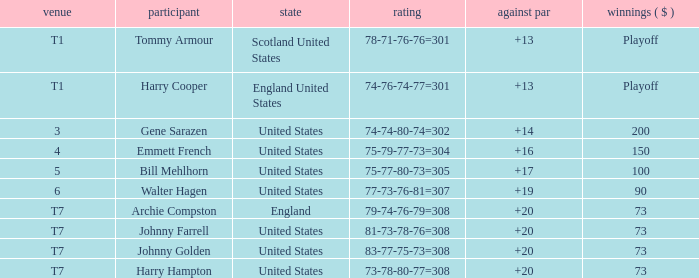What is the ranking when Archie Compston is the player and the money is $73? T7. Would you mind parsing the complete table? {'header': ['venue', 'participant', 'state', 'rating', 'against par', 'winnings ( $ )'], 'rows': [['T1', 'Tommy Armour', 'Scotland United States', '78-71-76-76=301', '+13', 'Playoff'], ['T1', 'Harry Cooper', 'England United States', '74-76-74-77=301', '+13', 'Playoff'], ['3', 'Gene Sarazen', 'United States', '74-74-80-74=302', '+14', '200'], ['4', 'Emmett French', 'United States', '75-79-77-73=304', '+16', '150'], ['5', 'Bill Mehlhorn', 'United States', '75-77-80-73=305', '+17', '100'], ['6', 'Walter Hagen', 'United States', '77-73-76-81=307', '+19', '90'], ['T7', 'Archie Compston', 'England', '79-74-76-79=308', '+20', '73'], ['T7', 'Johnny Farrell', 'United States', '81-73-78-76=308', '+20', '73'], ['T7', 'Johnny Golden', 'United States', '83-77-75-73=308', '+20', '73'], ['T7', 'Harry Hampton', 'United States', '73-78-80-77=308', '+20', '73']]} 